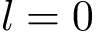<formula> <loc_0><loc_0><loc_500><loc_500>l = 0</formula> 